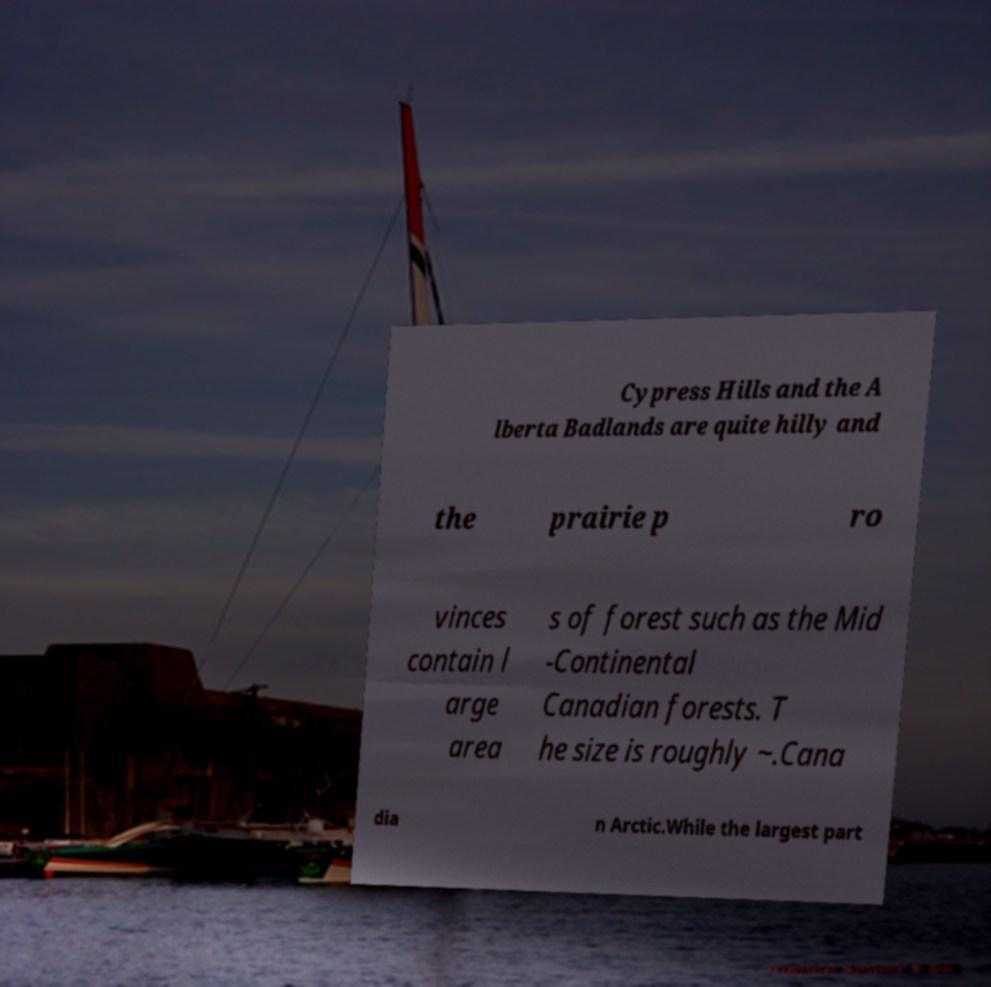For documentation purposes, I need the text within this image transcribed. Could you provide that? Cypress Hills and the A lberta Badlands are quite hilly and the prairie p ro vinces contain l arge area s of forest such as the Mid -Continental Canadian forests. T he size is roughly ~.Cana dia n Arctic.While the largest part 